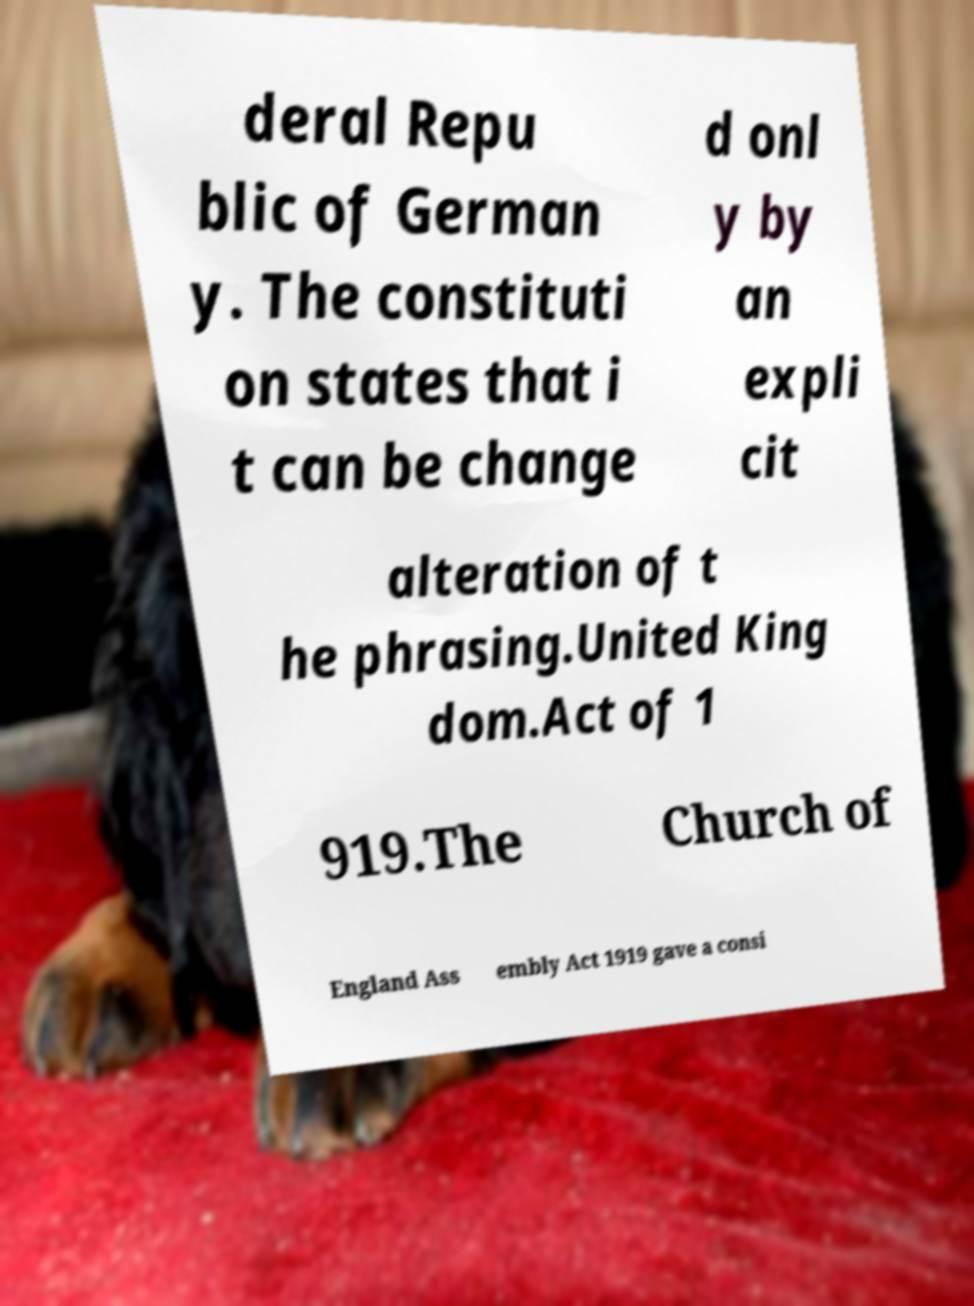What messages or text are displayed in this image? I need them in a readable, typed format. deral Repu blic of German y. The constituti on states that i t can be change d onl y by an expli cit alteration of t he phrasing.United King dom.Act of 1 919.The Church of England Ass embly Act 1919 gave a consi 